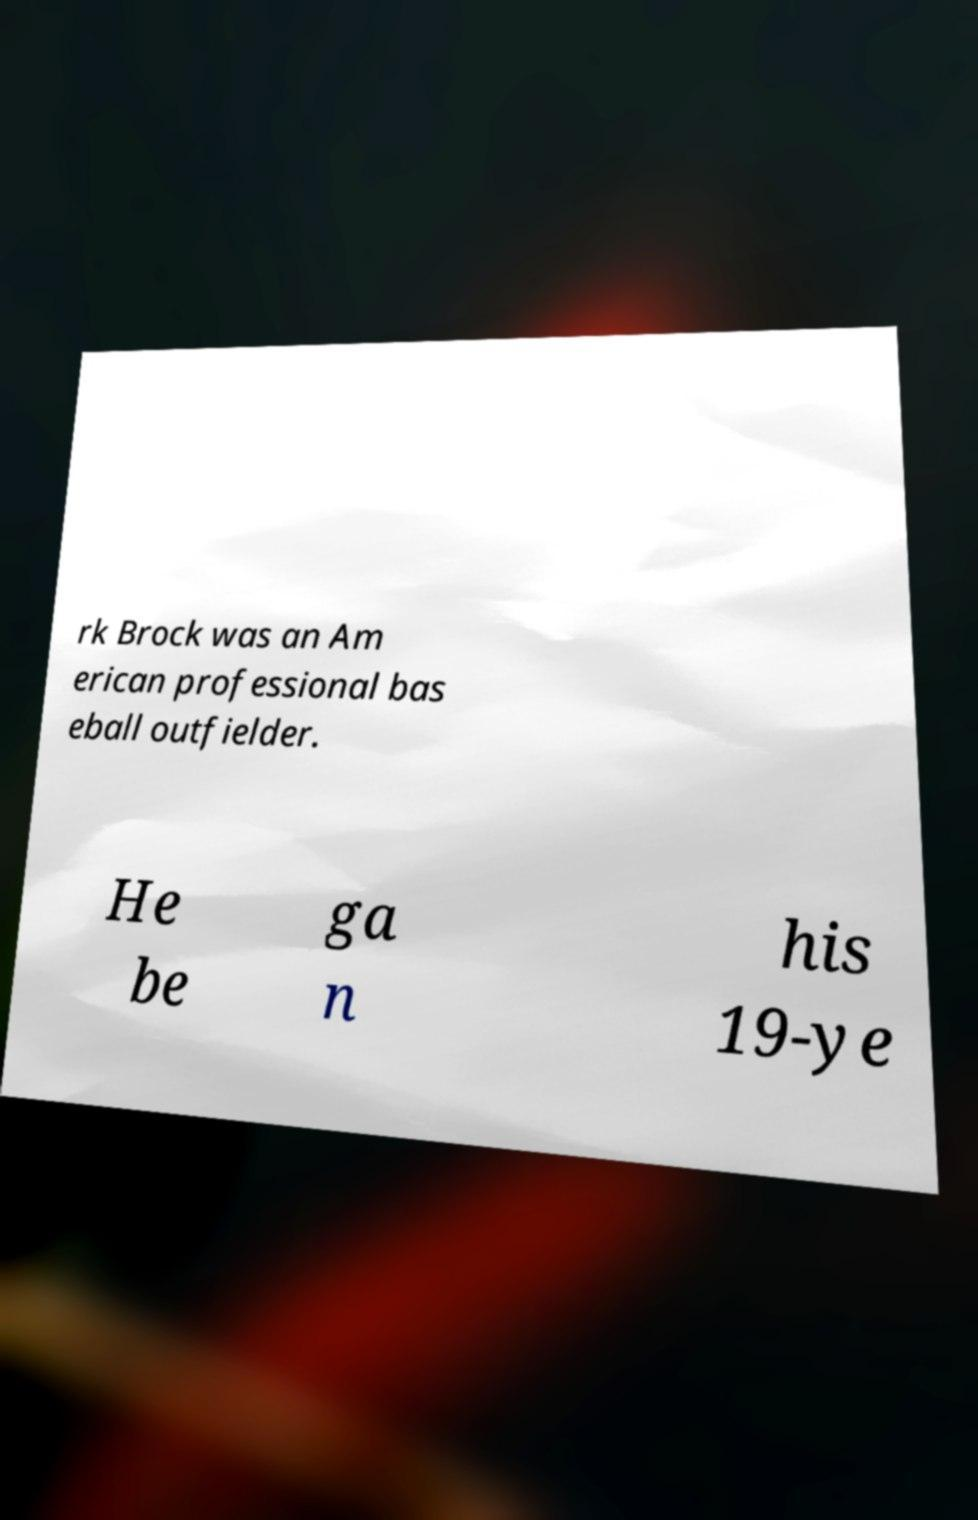I need the written content from this picture converted into text. Can you do that? rk Brock was an Am erican professional bas eball outfielder. He be ga n his 19-ye 